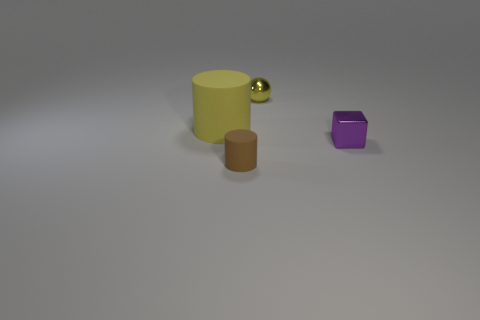How many small cylinders are the same material as the ball?
Make the answer very short. 0. There is a tiny shiny object to the left of the tiny purple shiny thing; what shape is it?
Keep it short and to the point. Sphere. Is the big object made of the same material as the yellow thing that is behind the big yellow matte cylinder?
Your answer should be compact. No. Are any small shiny spheres visible?
Your answer should be compact. Yes. There is a thing that is to the left of the cylinder that is in front of the purple metallic cube; is there a yellow matte cylinder on the left side of it?
Make the answer very short. No. What number of big things are gray rubber cylinders or brown cylinders?
Ensure brevity in your answer.  0. What is the color of the shiny ball that is the same size as the purple metallic cube?
Offer a terse response. Yellow. There is a tiny metal sphere; what number of matte things are to the left of it?
Offer a very short reply. 2. Are there any other balls that have the same material as the small ball?
Offer a terse response. No. The large rubber thing that is the same color as the ball is what shape?
Offer a very short reply. Cylinder. 